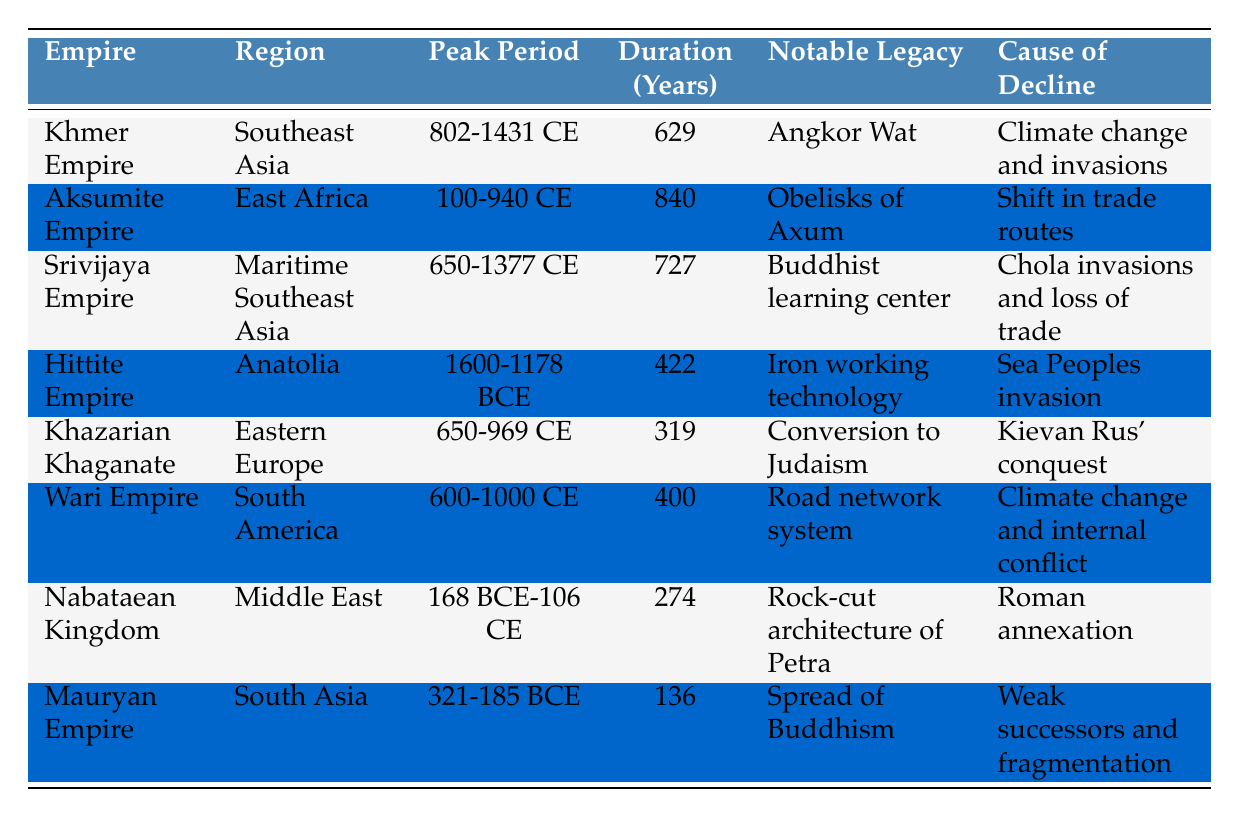What is the duration of the Aksumite Empire? The Aksumite Empire's duration is directly mentioned in the table as 840 years.
Answer: 840 years Which empire had the longest duration? By comparing the durations listed, the Aksumite Empire lasted for 840 years, which is the longest duration among the empires presented.
Answer: Aksumite Empire Did the Mauryan Empire have a longer duration than the Khazarian Khaganate? The Mauryan Empire lasted for 136 years, while the Khazarian Khaganate lasted for 319 years. Since 136 is less than 319, the statement is false.
Answer: No What notable legacy is associated with the Khmer Empire? The notable legacy of the Khmer Empire, as shown in the table, is Angkor Wat.
Answer: Angkor Wat Which two empires had climate change as a cause of decline? The Khmer Empire and the Wari Empire both list climate change as a cause of their decline according to the table.
Answer: Khmer Empire and Wari Empire What is the average duration of the empires listed? To find the average, first sum the durations: 629 + 840 + 727 + 422 + 319 + 400 + 274 + 136 = 3747. Then divide by 8 (the number of empires): 3747 / 8 = 468.375. Thus, the average duration is approximately 468 years.
Answer: 468 years Is it true that the Srivijaya Empire was in Southeast Asia? The table shows that the Srivijaya Empire is located in Maritime Southeast Asia, confirming that the statement is true.
Answer: Yes Which empire had the cause of decline listed as "Roman annexation"? According to the table, the Nabataean Kingdom had the cause of decline listed as Roman annexation.
Answer: Nabataean Kingdom How many years did the Hittite Empire last compared to the Khmer Empire? The Hittite Empire lasted for 422 years, while the Khmer Empire lasted for 629 years. Since 629 is greater than 422, the Khmer Empire lasted longer.
Answer: Khmer Empire lasted longer What notable legacy is associated with the obelisks found in the Aksumite Empire? The notable legacy linked to the Aksumite Empire is the Obelisks of Axum, as mentioned in the table.
Answer: Obelisks of Axum 